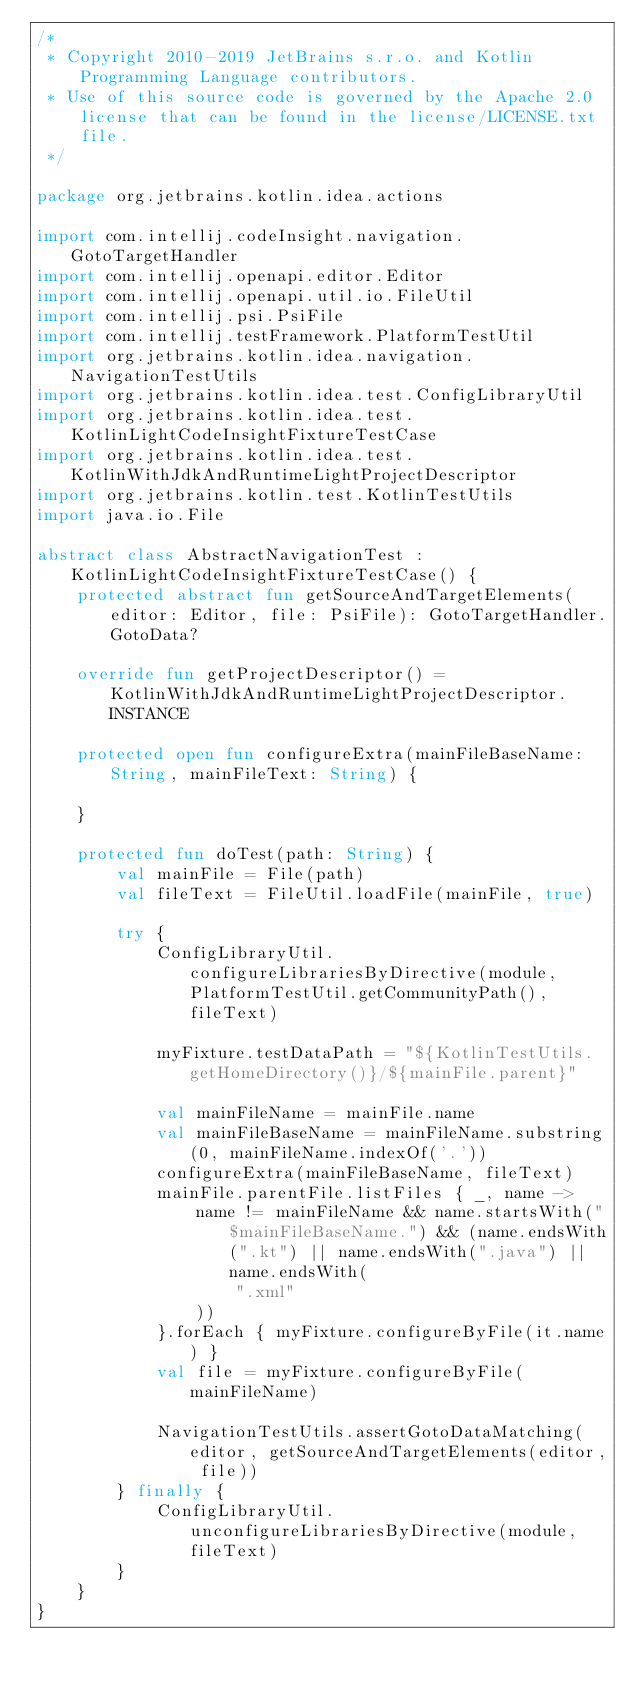<code> <loc_0><loc_0><loc_500><loc_500><_Kotlin_>/*
 * Copyright 2010-2019 JetBrains s.r.o. and Kotlin Programming Language contributors.
 * Use of this source code is governed by the Apache 2.0 license that can be found in the license/LICENSE.txt file.
 */

package org.jetbrains.kotlin.idea.actions

import com.intellij.codeInsight.navigation.GotoTargetHandler
import com.intellij.openapi.editor.Editor
import com.intellij.openapi.util.io.FileUtil
import com.intellij.psi.PsiFile
import com.intellij.testFramework.PlatformTestUtil
import org.jetbrains.kotlin.idea.navigation.NavigationTestUtils
import org.jetbrains.kotlin.idea.test.ConfigLibraryUtil
import org.jetbrains.kotlin.idea.test.KotlinLightCodeInsightFixtureTestCase
import org.jetbrains.kotlin.idea.test.KotlinWithJdkAndRuntimeLightProjectDescriptor
import org.jetbrains.kotlin.test.KotlinTestUtils
import java.io.File

abstract class AbstractNavigationTest : KotlinLightCodeInsightFixtureTestCase() {
    protected abstract fun getSourceAndTargetElements(editor: Editor, file: PsiFile): GotoTargetHandler.GotoData?

    override fun getProjectDescriptor() = KotlinWithJdkAndRuntimeLightProjectDescriptor.INSTANCE

    protected open fun configureExtra(mainFileBaseName: String, mainFileText: String) {

    }

    protected fun doTest(path: String) {
        val mainFile = File(path)
        val fileText = FileUtil.loadFile(mainFile, true)

        try {
            ConfigLibraryUtil.configureLibrariesByDirective(module, PlatformTestUtil.getCommunityPath(), fileText)

            myFixture.testDataPath = "${KotlinTestUtils.getHomeDirectory()}/${mainFile.parent}"

            val mainFileName = mainFile.name
            val mainFileBaseName = mainFileName.substring(0, mainFileName.indexOf('.'))
            configureExtra(mainFileBaseName, fileText)
            mainFile.parentFile.listFiles { _, name ->
                name != mainFileName && name.startsWith("$mainFileBaseName.") && (name.endsWith(".kt") || name.endsWith(".java") || name.endsWith(
                    ".xml"
                ))
            }.forEach { myFixture.configureByFile(it.name) }
            val file = myFixture.configureByFile(mainFileName)

            NavigationTestUtils.assertGotoDataMatching(editor, getSourceAndTargetElements(editor, file))
        } finally {
            ConfigLibraryUtil.unconfigureLibrariesByDirective(module, fileText)
        }
    }
}

</code> 